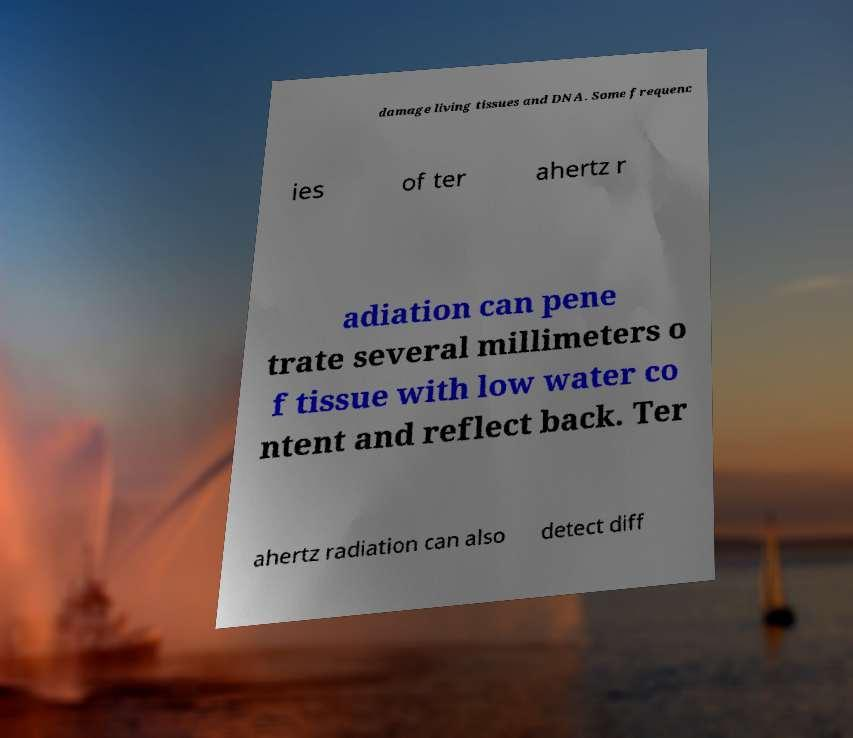Could you assist in decoding the text presented in this image and type it out clearly? damage living tissues and DNA. Some frequenc ies of ter ahertz r adiation can pene trate several millimeters o f tissue with low water co ntent and reflect back. Ter ahertz radiation can also detect diff 